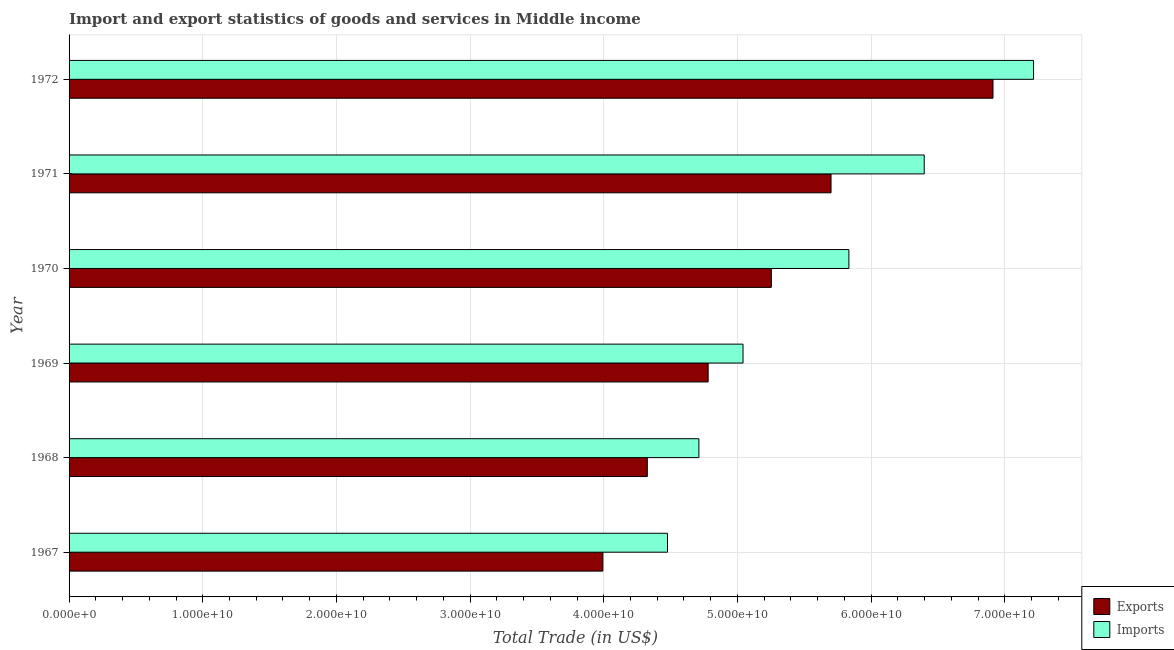Are the number of bars per tick equal to the number of legend labels?
Your response must be concise. Yes. How many bars are there on the 1st tick from the top?
Provide a succinct answer. 2. What is the label of the 1st group of bars from the top?
Keep it short and to the point. 1972. What is the imports of goods and services in 1967?
Your answer should be compact. 4.48e+1. Across all years, what is the maximum imports of goods and services?
Make the answer very short. 7.22e+1. Across all years, what is the minimum imports of goods and services?
Keep it short and to the point. 4.48e+1. In which year was the export of goods and services minimum?
Make the answer very short. 1967. What is the total export of goods and services in the graph?
Offer a very short reply. 3.10e+11. What is the difference between the imports of goods and services in 1971 and that in 1972?
Make the answer very short. -8.18e+09. What is the difference between the imports of goods and services in 1972 and the export of goods and services in 1970?
Ensure brevity in your answer.  1.96e+1. What is the average export of goods and services per year?
Your response must be concise. 5.16e+1. In the year 1971, what is the difference between the imports of goods and services and export of goods and services?
Your response must be concise. 6.97e+09. What is the ratio of the export of goods and services in 1970 to that in 1972?
Ensure brevity in your answer.  0.76. Is the imports of goods and services in 1970 less than that in 1971?
Ensure brevity in your answer.  Yes. What is the difference between the highest and the second highest imports of goods and services?
Your answer should be compact. 8.18e+09. What is the difference between the highest and the lowest imports of goods and services?
Your answer should be very brief. 2.74e+1. Is the sum of the export of goods and services in 1971 and 1972 greater than the maximum imports of goods and services across all years?
Provide a short and direct response. Yes. What does the 1st bar from the top in 1969 represents?
Give a very brief answer. Imports. What does the 1st bar from the bottom in 1971 represents?
Your answer should be compact. Exports. Does the graph contain grids?
Provide a short and direct response. Yes. How many legend labels are there?
Provide a succinct answer. 2. What is the title of the graph?
Keep it short and to the point. Import and export statistics of goods and services in Middle income. What is the label or title of the X-axis?
Keep it short and to the point. Total Trade (in US$). What is the label or title of the Y-axis?
Provide a short and direct response. Year. What is the Total Trade (in US$) in Exports in 1967?
Give a very brief answer. 3.99e+1. What is the Total Trade (in US$) in Imports in 1967?
Your response must be concise. 4.48e+1. What is the Total Trade (in US$) in Exports in 1968?
Offer a very short reply. 4.33e+1. What is the Total Trade (in US$) in Imports in 1968?
Make the answer very short. 4.71e+1. What is the Total Trade (in US$) of Exports in 1969?
Your answer should be compact. 4.78e+1. What is the Total Trade (in US$) in Imports in 1969?
Give a very brief answer. 5.04e+1. What is the Total Trade (in US$) of Exports in 1970?
Your answer should be compact. 5.25e+1. What is the Total Trade (in US$) of Imports in 1970?
Ensure brevity in your answer.  5.83e+1. What is the Total Trade (in US$) of Exports in 1971?
Make the answer very short. 5.70e+1. What is the Total Trade (in US$) of Imports in 1971?
Offer a very short reply. 6.40e+1. What is the Total Trade (in US$) of Exports in 1972?
Your response must be concise. 6.91e+1. What is the Total Trade (in US$) of Imports in 1972?
Offer a very short reply. 7.22e+1. Across all years, what is the maximum Total Trade (in US$) in Exports?
Your response must be concise. 6.91e+1. Across all years, what is the maximum Total Trade (in US$) in Imports?
Make the answer very short. 7.22e+1. Across all years, what is the minimum Total Trade (in US$) in Exports?
Provide a short and direct response. 3.99e+1. Across all years, what is the minimum Total Trade (in US$) in Imports?
Your answer should be very brief. 4.48e+1. What is the total Total Trade (in US$) of Exports in the graph?
Provide a short and direct response. 3.10e+11. What is the total Total Trade (in US$) in Imports in the graph?
Give a very brief answer. 3.37e+11. What is the difference between the Total Trade (in US$) of Exports in 1967 and that in 1968?
Give a very brief answer. -3.33e+09. What is the difference between the Total Trade (in US$) of Imports in 1967 and that in 1968?
Give a very brief answer. -2.35e+09. What is the difference between the Total Trade (in US$) in Exports in 1967 and that in 1969?
Your answer should be very brief. -7.88e+09. What is the difference between the Total Trade (in US$) of Imports in 1967 and that in 1969?
Offer a very short reply. -5.65e+09. What is the difference between the Total Trade (in US$) of Exports in 1967 and that in 1970?
Offer a very short reply. -1.26e+1. What is the difference between the Total Trade (in US$) in Imports in 1967 and that in 1970?
Ensure brevity in your answer.  -1.36e+1. What is the difference between the Total Trade (in US$) of Exports in 1967 and that in 1971?
Ensure brevity in your answer.  -1.71e+1. What is the difference between the Total Trade (in US$) of Imports in 1967 and that in 1971?
Provide a succinct answer. -1.92e+1. What is the difference between the Total Trade (in US$) in Exports in 1967 and that in 1972?
Your answer should be compact. -2.92e+1. What is the difference between the Total Trade (in US$) in Imports in 1967 and that in 1972?
Offer a very short reply. -2.74e+1. What is the difference between the Total Trade (in US$) of Exports in 1968 and that in 1969?
Your answer should be compact. -4.55e+09. What is the difference between the Total Trade (in US$) in Imports in 1968 and that in 1969?
Your answer should be very brief. -3.30e+09. What is the difference between the Total Trade (in US$) of Exports in 1968 and that in 1970?
Give a very brief answer. -9.28e+09. What is the difference between the Total Trade (in US$) in Imports in 1968 and that in 1970?
Provide a short and direct response. -1.12e+1. What is the difference between the Total Trade (in US$) of Exports in 1968 and that in 1971?
Offer a terse response. -1.37e+1. What is the difference between the Total Trade (in US$) in Imports in 1968 and that in 1971?
Offer a very short reply. -1.69e+1. What is the difference between the Total Trade (in US$) of Exports in 1968 and that in 1972?
Provide a short and direct response. -2.59e+1. What is the difference between the Total Trade (in US$) of Imports in 1968 and that in 1972?
Give a very brief answer. -2.50e+1. What is the difference between the Total Trade (in US$) of Exports in 1969 and that in 1970?
Offer a very short reply. -4.73e+09. What is the difference between the Total Trade (in US$) in Imports in 1969 and that in 1970?
Offer a very short reply. -7.92e+09. What is the difference between the Total Trade (in US$) of Exports in 1969 and that in 1971?
Your answer should be compact. -9.19e+09. What is the difference between the Total Trade (in US$) in Imports in 1969 and that in 1971?
Give a very brief answer. -1.36e+1. What is the difference between the Total Trade (in US$) of Exports in 1969 and that in 1972?
Provide a succinct answer. -2.13e+1. What is the difference between the Total Trade (in US$) in Imports in 1969 and that in 1972?
Your answer should be very brief. -2.17e+1. What is the difference between the Total Trade (in US$) of Exports in 1970 and that in 1971?
Your answer should be very brief. -4.46e+09. What is the difference between the Total Trade (in US$) in Imports in 1970 and that in 1971?
Offer a terse response. -5.64e+09. What is the difference between the Total Trade (in US$) in Exports in 1970 and that in 1972?
Provide a short and direct response. -1.66e+1. What is the difference between the Total Trade (in US$) of Imports in 1970 and that in 1972?
Offer a terse response. -1.38e+1. What is the difference between the Total Trade (in US$) in Exports in 1971 and that in 1972?
Ensure brevity in your answer.  -1.21e+1. What is the difference between the Total Trade (in US$) of Imports in 1971 and that in 1972?
Offer a very short reply. -8.18e+09. What is the difference between the Total Trade (in US$) of Exports in 1967 and the Total Trade (in US$) of Imports in 1968?
Make the answer very short. -7.19e+09. What is the difference between the Total Trade (in US$) of Exports in 1967 and the Total Trade (in US$) of Imports in 1969?
Your answer should be very brief. -1.05e+1. What is the difference between the Total Trade (in US$) of Exports in 1967 and the Total Trade (in US$) of Imports in 1970?
Make the answer very short. -1.84e+1. What is the difference between the Total Trade (in US$) in Exports in 1967 and the Total Trade (in US$) in Imports in 1971?
Offer a terse response. -2.40e+1. What is the difference between the Total Trade (in US$) in Exports in 1967 and the Total Trade (in US$) in Imports in 1972?
Make the answer very short. -3.22e+1. What is the difference between the Total Trade (in US$) of Exports in 1968 and the Total Trade (in US$) of Imports in 1969?
Give a very brief answer. -7.16e+09. What is the difference between the Total Trade (in US$) in Exports in 1968 and the Total Trade (in US$) in Imports in 1970?
Offer a terse response. -1.51e+1. What is the difference between the Total Trade (in US$) in Exports in 1968 and the Total Trade (in US$) in Imports in 1971?
Keep it short and to the point. -2.07e+1. What is the difference between the Total Trade (in US$) in Exports in 1968 and the Total Trade (in US$) in Imports in 1972?
Keep it short and to the point. -2.89e+1. What is the difference between the Total Trade (in US$) of Exports in 1969 and the Total Trade (in US$) of Imports in 1970?
Provide a short and direct response. -1.05e+1. What is the difference between the Total Trade (in US$) of Exports in 1969 and the Total Trade (in US$) of Imports in 1971?
Keep it short and to the point. -1.62e+1. What is the difference between the Total Trade (in US$) of Exports in 1969 and the Total Trade (in US$) of Imports in 1972?
Your answer should be very brief. -2.43e+1. What is the difference between the Total Trade (in US$) in Exports in 1970 and the Total Trade (in US$) in Imports in 1971?
Make the answer very short. -1.14e+1. What is the difference between the Total Trade (in US$) in Exports in 1970 and the Total Trade (in US$) in Imports in 1972?
Offer a terse response. -1.96e+1. What is the difference between the Total Trade (in US$) in Exports in 1971 and the Total Trade (in US$) in Imports in 1972?
Offer a terse response. -1.52e+1. What is the average Total Trade (in US$) of Exports per year?
Keep it short and to the point. 5.16e+1. What is the average Total Trade (in US$) in Imports per year?
Offer a terse response. 5.61e+1. In the year 1967, what is the difference between the Total Trade (in US$) in Exports and Total Trade (in US$) in Imports?
Provide a succinct answer. -4.84e+09. In the year 1968, what is the difference between the Total Trade (in US$) in Exports and Total Trade (in US$) in Imports?
Your response must be concise. -3.86e+09. In the year 1969, what is the difference between the Total Trade (in US$) in Exports and Total Trade (in US$) in Imports?
Keep it short and to the point. -2.61e+09. In the year 1970, what is the difference between the Total Trade (in US$) in Exports and Total Trade (in US$) in Imports?
Your answer should be compact. -5.80e+09. In the year 1971, what is the difference between the Total Trade (in US$) in Exports and Total Trade (in US$) in Imports?
Provide a short and direct response. -6.97e+09. In the year 1972, what is the difference between the Total Trade (in US$) of Exports and Total Trade (in US$) of Imports?
Your response must be concise. -3.04e+09. What is the ratio of the Total Trade (in US$) of Exports in 1967 to that in 1968?
Give a very brief answer. 0.92. What is the ratio of the Total Trade (in US$) in Imports in 1967 to that in 1968?
Your answer should be compact. 0.95. What is the ratio of the Total Trade (in US$) in Exports in 1967 to that in 1969?
Provide a succinct answer. 0.84. What is the ratio of the Total Trade (in US$) in Imports in 1967 to that in 1969?
Provide a short and direct response. 0.89. What is the ratio of the Total Trade (in US$) in Exports in 1967 to that in 1970?
Your answer should be very brief. 0.76. What is the ratio of the Total Trade (in US$) in Imports in 1967 to that in 1970?
Give a very brief answer. 0.77. What is the ratio of the Total Trade (in US$) in Exports in 1967 to that in 1971?
Offer a very short reply. 0.7. What is the ratio of the Total Trade (in US$) of Imports in 1967 to that in 1971?
Provide a short and direct response. 0.7. What is the ratio of the Total Trade (in US$) of Exports in 1967 to that in 1972?
Make the answer very short. 0.58. What is the ratio of the Total Trade (in US$) of Imports in 1967 to that in 1972?
Give a very brief answer. 0.62. What is the ratio of the Total Trade (in US$) of Exports in 1968 to that in 1969?
Your answer should be compact. 0.9. What is the ratio of the Total Trade (in US$) of Imports in 1968 to that in 1969?
Your response must be concise. 0.93. What is the ratio of the Total Trade (in US$) in Exports in 1968 to that in 1970?
Your answer should be very brief. 0.82. What is the ratio of the Total Trade (in US$) in Imports in 1968 to that in 1970?
Offer a very short reply. 0.81. What is the ratio of the Total Trade (in US$) of Exports in 1968 to that in 1971?
Provide a succinct answer. 0.76. What is the ratio of the Total Trade (in US$) of Imports in 1968 to that in 1971?
Your answer should be very brief. 0.74. What is the ratio of the Total Trade (in US$) of Exports in 1968 to that in 1972?
Give a very brief answer. 0.63. What is the ratio of the Total Trade (in US$) of Imports in 1968 to that in 1972?
Provide a succinct answer. 0.65. What is the ratio of the Total Trade (in US$) of Exports in 1969 to that in 1970?
Ensure brevity in your answer.  0.91. What is the ratio of the Total Trade (in US$) of Imports in 1969 to that in 1970?
Provide a succinct answer. 0.86. What is the ratio of the Total Trade (in US$) in Exports in 1969 to that in 1971?
Your answer should be compact. 0.84. What is the ratio of the Total Trade (in US$) in Imports in 1969 to that in 1971?
Your answer should be compact. 0.79. What is the ratio of the Total Trade (in US$) in Exports in 1969 to that in 1972?
Give a very brief answer. 0.69. What is the ratio of the Total Trade (in US$) of Imports in 1969 to that in 1972?
Keep it short and to the point. 0.7. What is the ratio of the Total Trade (in US$) in Exports in 1970 to that in 1971?
Ensure brevity in your answer.  0.92. What is the ratio of the Total Trade (in US$) of Imports in 1970 to that in 1971?
Offer a very short reply. 0.91. What is the ratio of the Total Trade (in US$) in Exports in 1970 to that in 1972?
Keep it short and to the point. 0.76. What is the ratio of the Total Trade (in US$) in Imports in 1970 to that in 1972?
Offer a very short reply. 0.81. What is the ratio of the Total Trade (in US$) of Exports in 1971 to that in 1972?
Provide a short and direct response. 0.82. What is the ratio of the Total Trade (in US$) in Imports in 1971 to that in 1972?
Give a very brief answer. 0.89. What is the difference between the highest and the second highest Total Trade (in US$) in Exports?
Your answer should be very brief. 1.21e+1. What is the difference between the highest and the second highest Total Trade (in US$) in Imports?
Your response must be concise. 8.18e+09. What is the difference between the highest and the lowest Total Trade (in US$) of Exports?
Provide a succinct answer. 2.92e+1. What is the difference between the highest and the lowest Total Trade (in US$) in Imports?
Make the answer very short. 2.74e+1. 